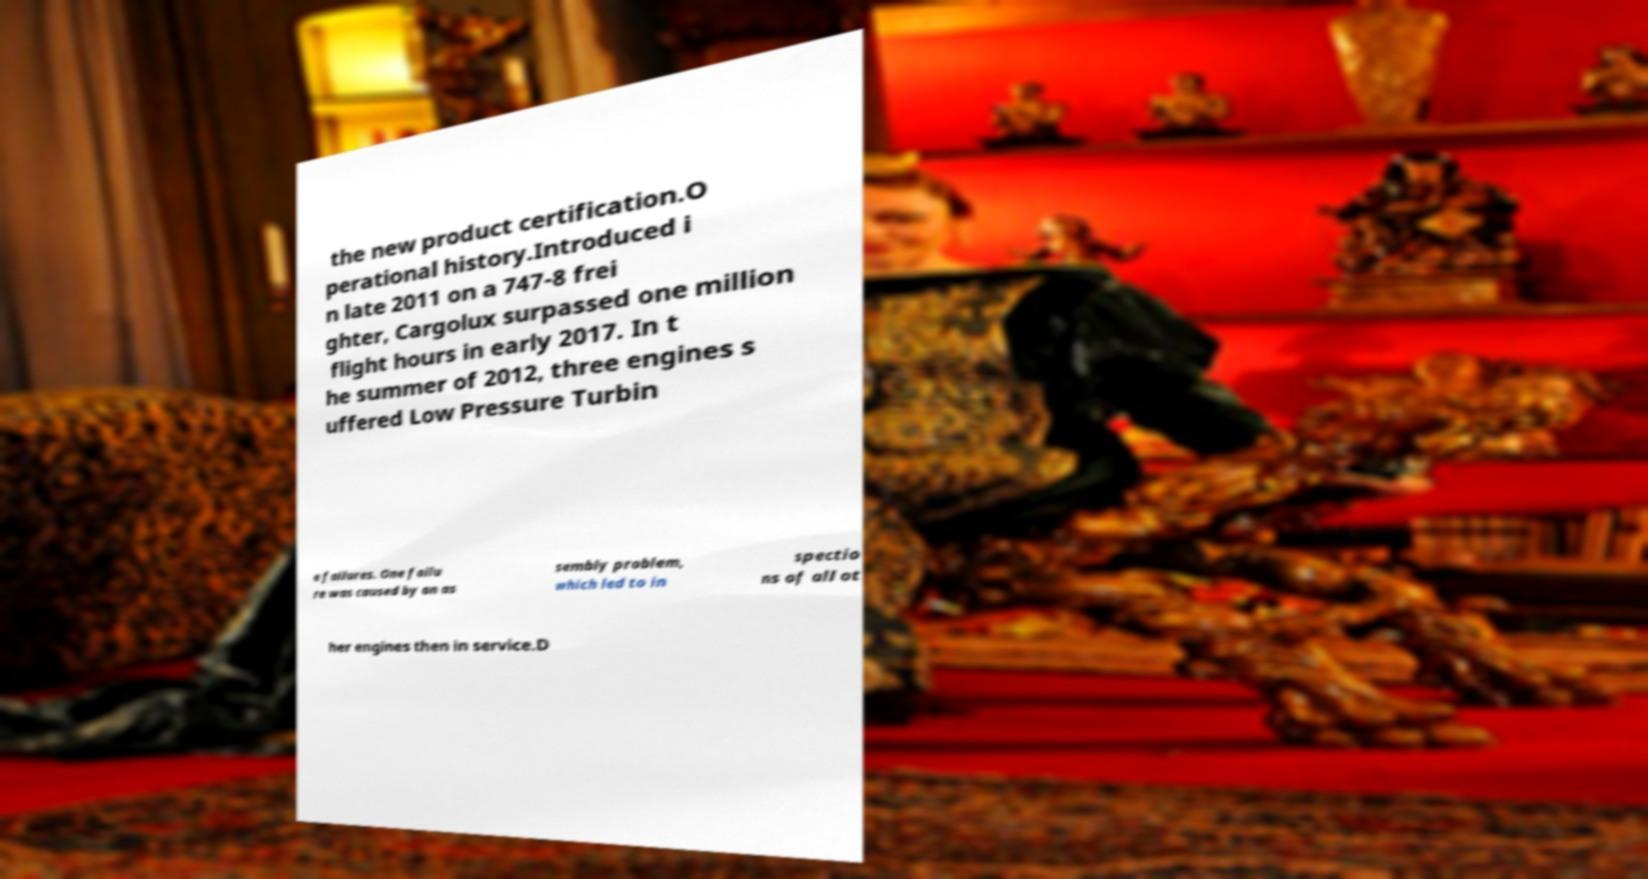Please identify and transcribe the text found in this image. the new product certification.O perational history.Introduced i n late 2011 on a 747-8 frei ghter, Cargolux surpassed one million flight hours in early 2017. In t he summer of 2012, three engines s uffered Low Pressure Turbin e failures. One failu re was caused by an as sembly problem, which led to in spectio ns of all ot her engines then in service.D 